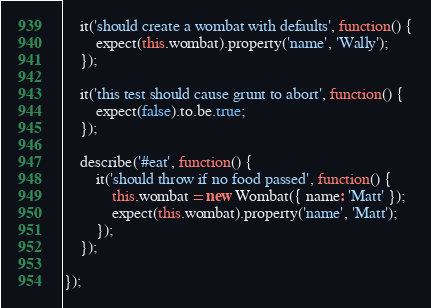Convert code to text. <code><loc_0><loc_0><loc_500><loc_500><_JavaScript_>    it('should create a wombat with defaults', function() {
        expect(this.wombat).property('name', 'Wally');
    });

    it('this test should cause grunt to abort', function() {
        expect(false).to.be.true;
    });

    describe('#eat', function() {
        it('should throw if no food passed', function() {
            this.wombat = new Wombat({ name: 'Matt' });
            expect(this.wombat).property('name', 'Matt');
        });
    });

});
</code> 